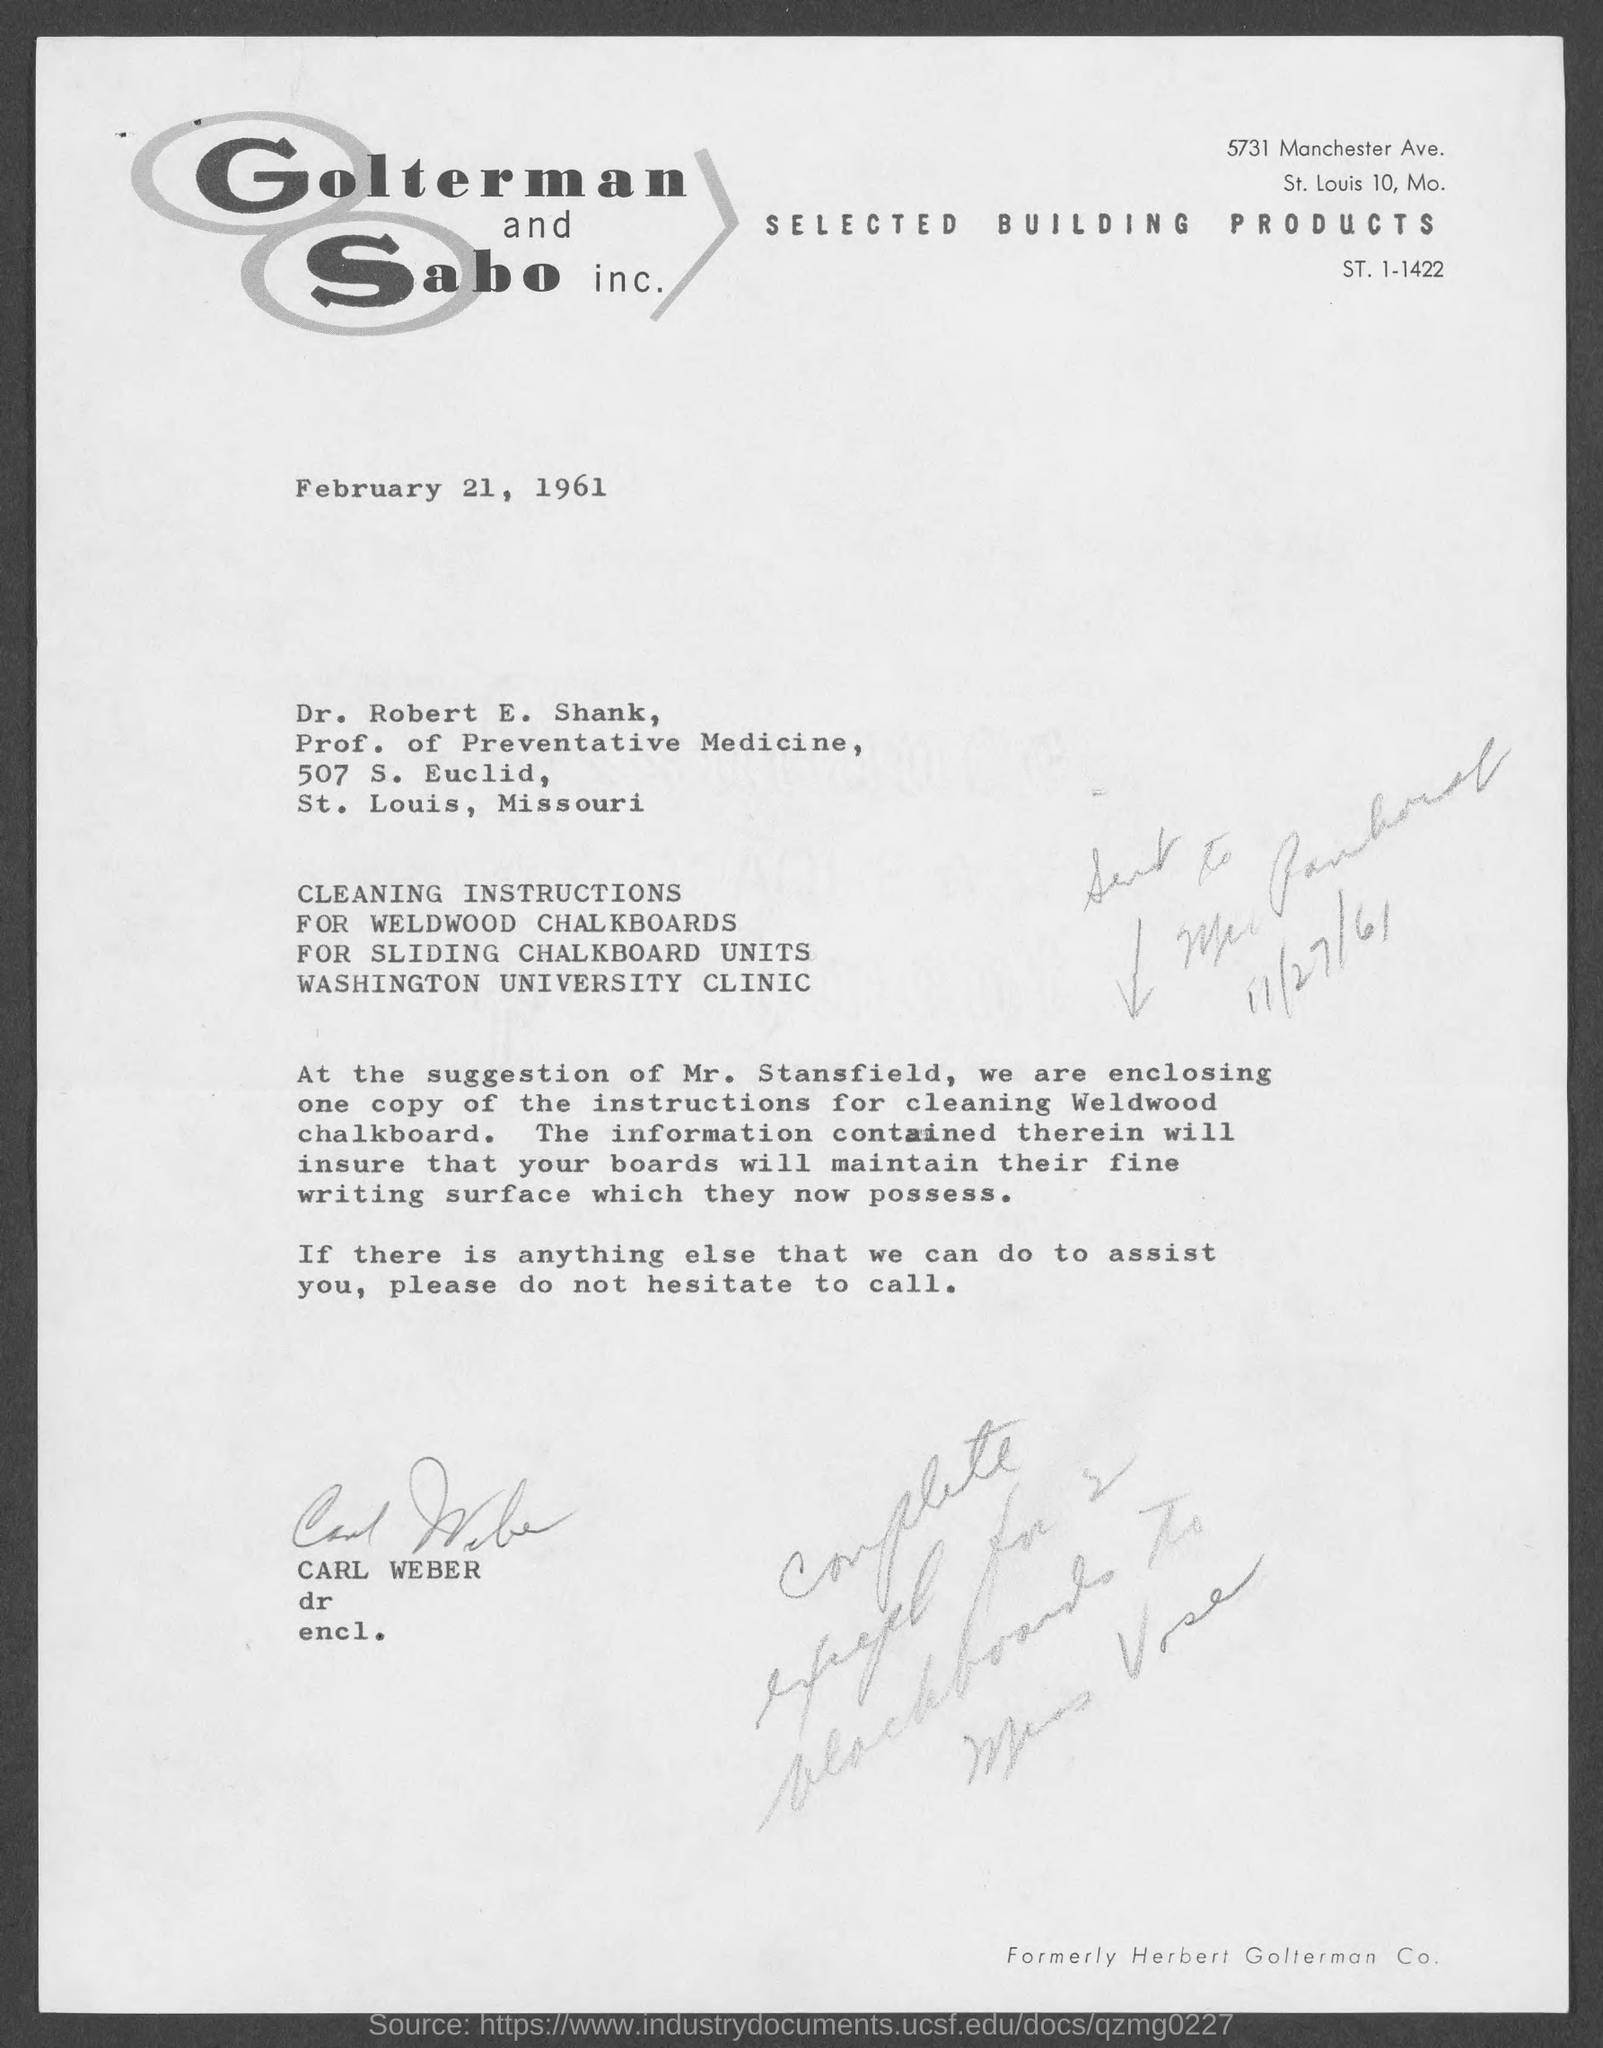What is date of the letter?
Provide a short and direct response. February 21, 1961. To whom,this letter is sent ?
Offer a very short reply. Dr. Robert E. Shank. Who sent the letter ?
Offer a terse response. CARL WEBER. Who is the 'Prof. of Preventative Medicine' ?
Your response must be concise. Dr. Robert E. Shank. 